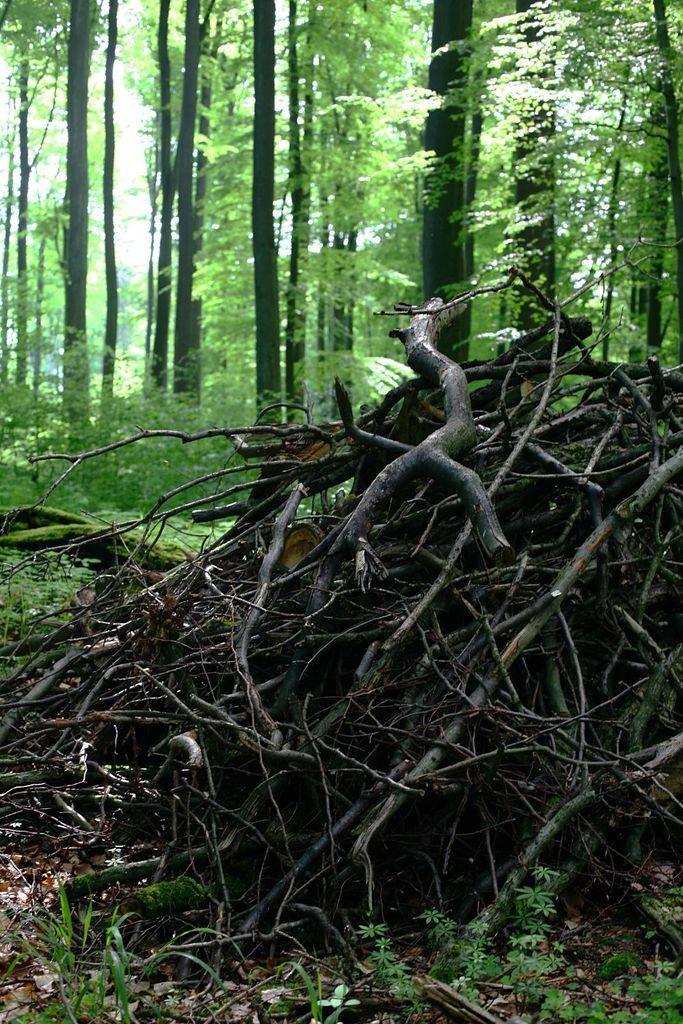What type of vegetation can be seen in the image? There are tree stems, plants, and trees in the image. Can you describe the specific features of the vegetation in the image? The image shows tree stems, plants, and trees, which are all types of vegetation. How many different types of vegetation are present in the image? There are three different types of vegetation present in the image: tree stems, plants, and trees. What is the name of the invention that is being used to grow the plants in the image? There is no invention present in the image; it simply shows plants, trees, and tree stems. Is there a committee meeting in the image? There is no committee meeting present in the image; it only shows plants, trees, and tree stems. 